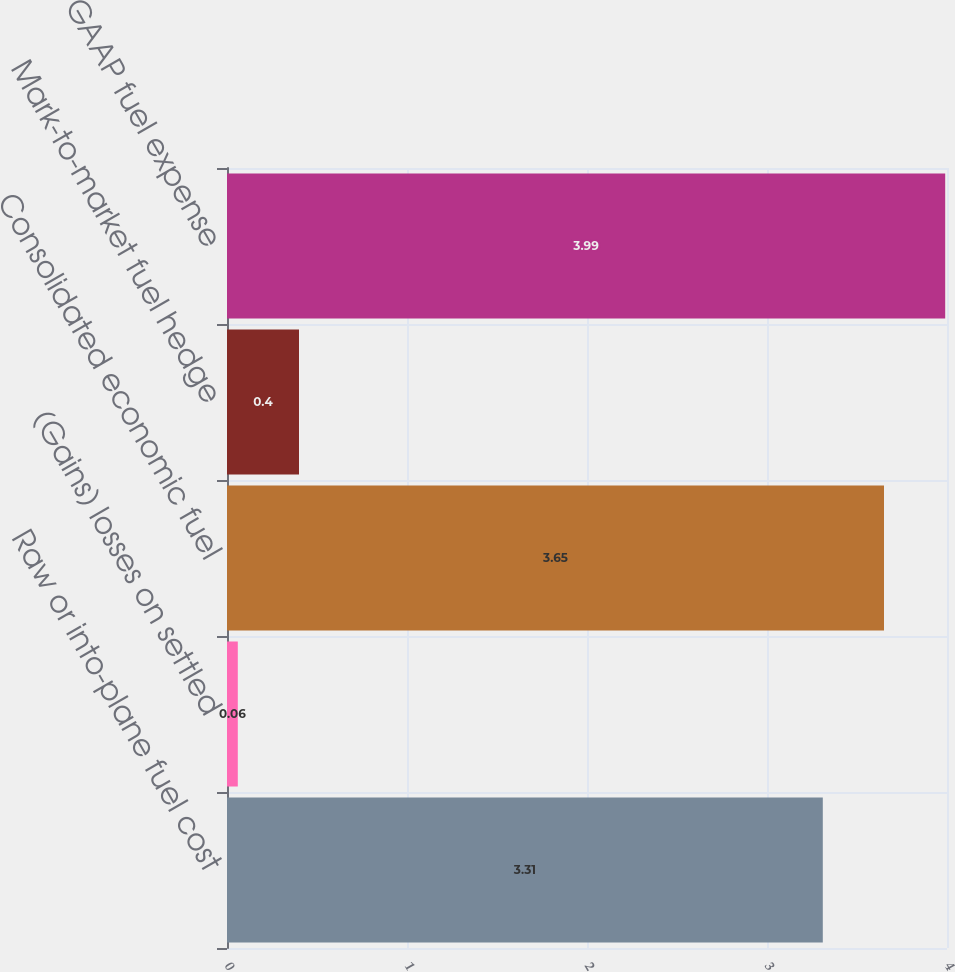Convert chart to OTSL. <chart><loc_0><loc_0><loc_500><loc_500><bar_chart><fcel>Raw or into-plane fuel cost<fcel>(Gains) losses on settled<fcel>Consolidated economic fuel<fcel>Mark-to-market fuel hedge<fcel>GAAP fuel expense<nl><fcel>3.31<fcel>0.06<fcel>3.65<fcel>0.4<fcel>3.99<nl></chart> 